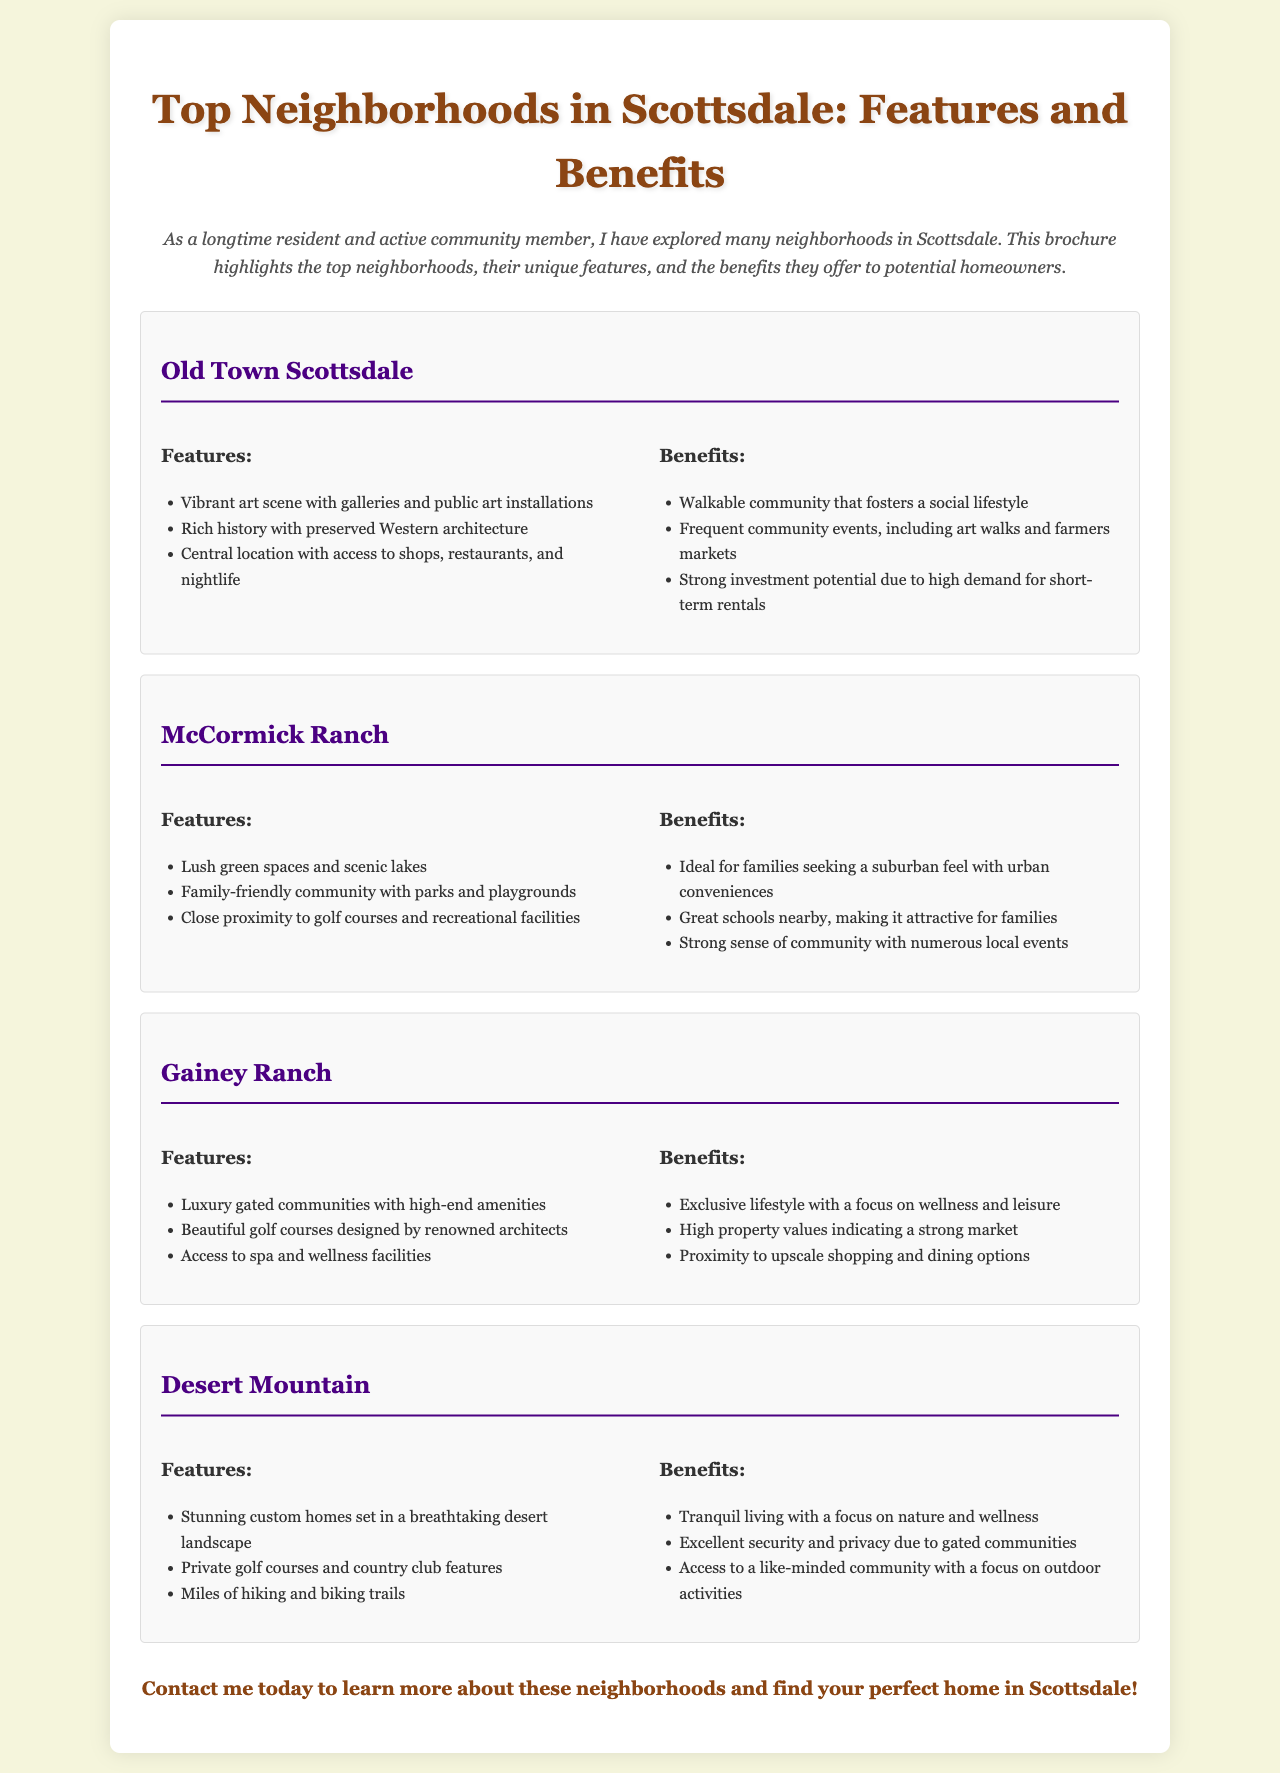What are the features of Old Town Scottsdale? The features of Old Town Scottsdale include a vibrant art scene, rich history, and central location.
Answer: Vibrant art scene with galleries and public art installations, Rich history with preserved Western architecture, Central location with access to shops, restaurants, and nightlife What benefits does McCormick Ranch offer? The benefits of McCormick Ranch include family-friendly amenities and a community atmosphere.
Answer: Ideal for families seeking a suburban feel with urban conveniences, Great schools nearby, Strong sense of community with numerous local events What type of community is Gainey Ranch? Gainey Ranch is characterized by luxury living and high-end amenities.
Answer: Luxury gated communities with high-end amenities How many neighborhoods are featured in this brochure? The document highlights a total of four neighborhoods in Scottsdale.
Answer: Four neighborhoods What activity can residents of Desert Mountain enjoy? Residents of Desert Mountain can enjoy outdoor activities in a private and tranquil setting.
Answer: Miles of hiking and biking trails Which neighborhood is located centrally and known for its art scene? The neighborhood known for its central location and art scene is Old Town Scottsdale.
Answer: Old Town Scottsdale What kind of events are common in Old Town Scottsdale? The common events in Old Town Scottsdale include art walks and farmers markets.
Answer: Art walks and farmers markets What is a specific feature of McCormick Ranch? One specific feature of McCormick Ranch is its lush green spaces.
Answer: Lush green spaces and scenic lakes 